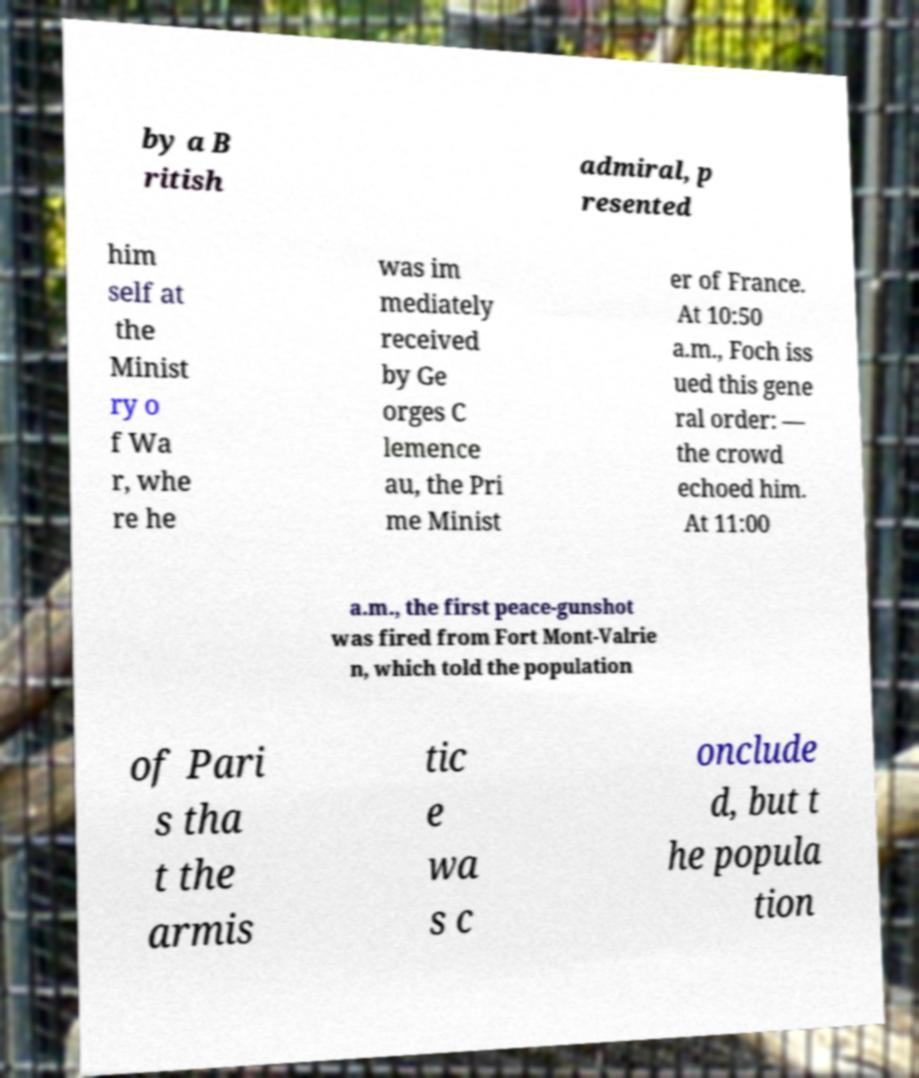Please identify and transcribe the text found in this image. by a B ritish admiral, p resented him self at the Minist ry o f Wa r, whe re he was im mediately received by Ge orges C lemence au, the Pri me Minist er of France. At 10:50 a.m., Foch iss ued this gene ral order: — the crowd echoed him. At 11:00 a.m., the first peace-gunshot was fired from Fort Mont-Valrie n, which told the population of Pari s tha t the armis tic e wa s c onclude d, but t he popula tion 